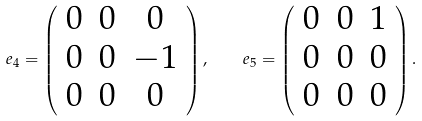<formula> <loc_0><loc_0><loc_500><loc_500>e _ { 4 } = \left ( \begin{array} { c c c } 0 & 0 & 0 \\ 0 & 0 & - 1 \\ 0 & 0 & 0 \\ \end{array} \right ) , \quad e _ { 5 } = \left ( \begin{array} { c c c } 0 & 0 & 1 \\ 0 & 0 & 0 \\ 0 & 0 & 0 \\ \end{array} \right ) .</formula> 